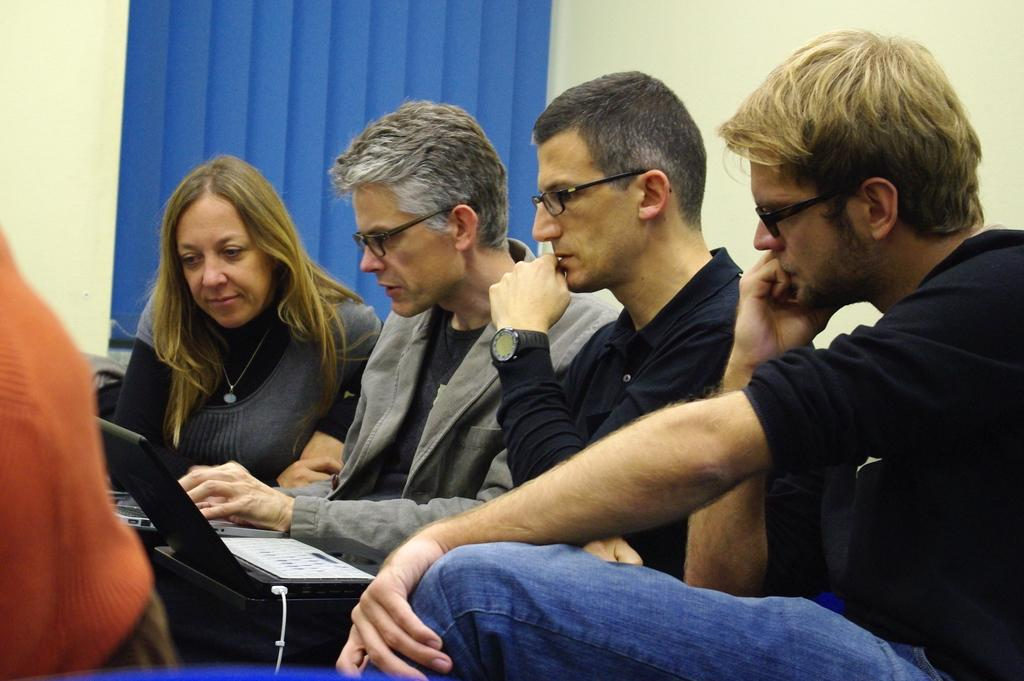How many people are present in the image? There are four people in the image. What are the people doing in the image? The people are sitting and discussing something. What are the people using while discussing? The people are operating laptops. What is visible behind the people? There is a wall behind the people. What architectural feature can be seen on the left side of the image? There is a window on the left side of the image. How many babies are crawling on the floor in the image? There are no babies present in the image; it features four people sitting and discussing while operating laptops. 